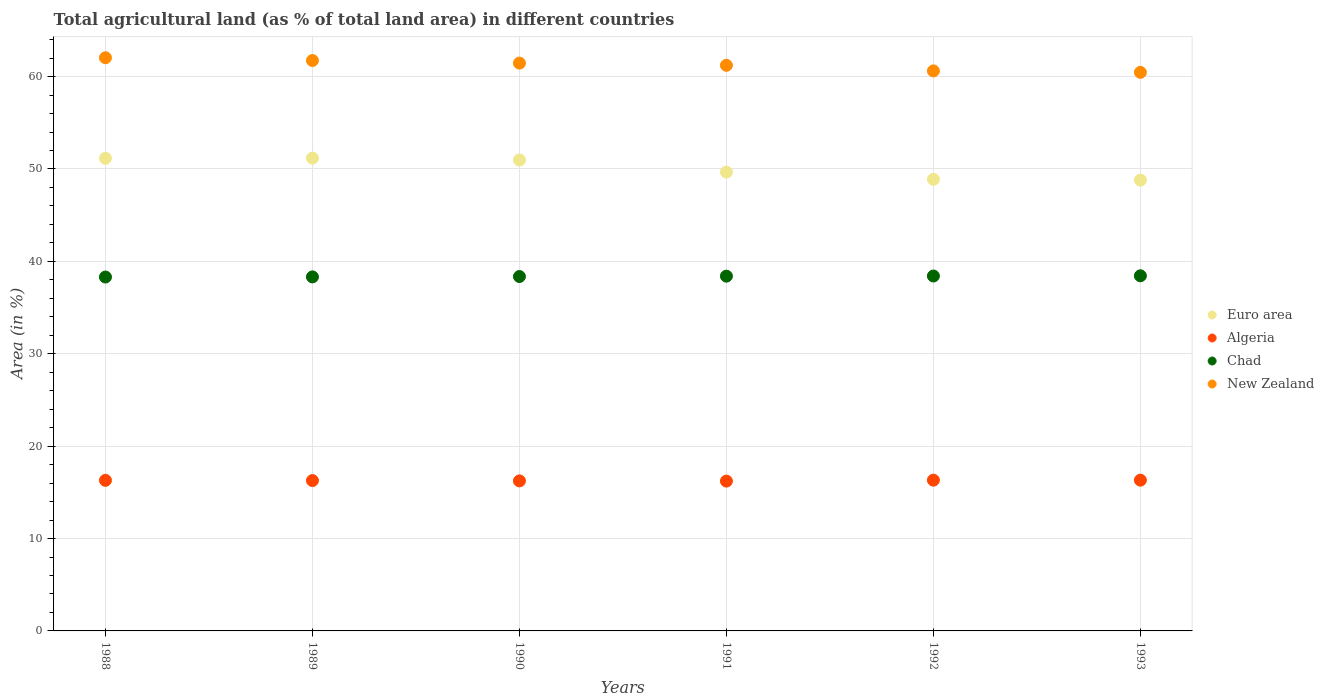How many different coloured dotlines are there?
Your answer should be compact. 4. Is the number of dotlines equal to the number of legend labels?
Make the answer very short. Yes. What is the percentage of agricultural land in Euro area in 1990?
Provide a short and direct response. 50.97. Across all years, what is the maximum percentage of agricultural land in Algeria?
Give a very brief answer. 16.32. Across all years, what is the minimum percentage of agricultural land in Algeria?
Offer a very short reply. 16.22. In which year was the percentage of agricultural land in Euro area maximum?
Your response must be concise. 1989. What is the total percentage of agricultural land in New Zealand in the graph?
Make the answer very short. 367.52. What is the difference between the percentage of agricultural land in Algeria in 1991 and that in 1993?
Provide a succinct answer. -0.1. What is the difference between the percentage of agricultural land in Algeria in 1993 and the percentage of agricultural land in New Zealand in 1989?
Give a very brief answer. -45.42. What is the average percentage of agricultural land in Chad per year?
Give a very brief answer. 38.37. In the year 1992, what is the difference between the percentage of agricultural land in Algeria and percentage of agricultural land in Chad?
Offer a very short reply. -22.1. In how many years, is the percentage of agricultural land in Euro area greater than 44 %?
Offer a terse response. 6. What is the ratio of the percentage of agricultural land in New Zealand in 1988 to that in 1991?
Keep it short and to the point. 1.01. What is the difference between the highest and the second highest percentage of agricultural land in Chad?
Provide a succinct answer. 0.02. What is the difference between the highest and the lowest percentage of agricultural land in Euro area?
Your answer should be compact. 2.38. In how many years, is the percentage of agricultural land in Algeria greater than the average percentage of agricultural land in Algeria taken over all years?
Offer a very short reply. 3. Is it the case that in every year, the sum of the percentage of agricultural land in Chad and percentage of agricultural land in New Zealand  is greater than the percentage of agricultural land in Euro area?
Keep it short and to the point. Yes. Does the percentage of agricultural land in Chad monotonically increase over the years?
Make the answer very short. Yes. Is the percentage of agricultural land in Chad strictly greater than the percentage of agricultural land in Euro area over the years?
Your response must be concise. No. What is the difference between two consecutive major ticks on the Y-axis?
Keep it short and to the point. 10. Are the values on the major ticks of Y-axis written in scientific E-notation?
Keep it short and to the point. No. Does the graph contain any zero values?
Give a very brief answer. No. What is the title of the graph?
Provide a short and direct response. Total agricultural land (as % of total land area) in different countries. What is the label or title of the X-axis?
Offer a terse response. Years. What is the label or title of the Y-axis?
Offer a terse response. Area (in %). What is the Area (in %) of Euro area in 1988?
Give a very brief answer. 51.15. What is the Area (in %) in Algeria in 1988?
Keep it short and to the point. 16.3. What is the Area (in %) in Chad in 1988?
Provide a succinct answer. 38.3. What is the Area (in %) of New Zealand in 1988?
Your answer should be very brief. 62.04. What is the Area (in %) in Euro area in 1989?
Make the answer very short. 51.18. What is the Area (in %) of Algeria in 1989?
Your answer should be very brief. 16.27. What is the Area (in %) in Chad in 1989?
Your answer should be very brief. 38.32. What is the Area (in %) of New Zealand in 1989?
Your answer should be very brief. 61.74. What is the Area (in %) in Euro area in 1990?
Offer a very short reply. 50.97. What is the Area (in %) in Algeria in 1990?
Your answer should be very brief. 16.24. What is the Area (in %) of Chad in 1990?
Ensure brevity in your answer.  38.36. What is the Area (in %) of New Zealand in 1990?
Provide a succinct answer. 61.46. What is the Area (in %) of Euro area in 1991?
Your answer should be very brief. 49.66. What is the Area (in %) in Algeria in 1991?
Your response must be concise. 16.22. What is the Area (in %) of Chad in 1991?
Provide a succinct answer. 38.4. What is the Area (in %) in New Zealand in 1991?
Ensure brevity in your answer.  61.22. What is the Area (in %) in Euro area in 1992?
Offer a terse response. 48.88. What is the Area (in %) of Algeria in 1992?
Make the answer very short. 16.32. What is the Area (in %) of Chad in 1992?
Give a very brief answer. 38.41. What is the Area (in %) of New Zealand in 1992?
Your answer should be very brief. 60.61. What is the Area (in %) of Euro area in 1993?
Give a very brief answer. 48.79. What is the Area (in %) in Algeria in 1993?
Give a very brief answer. 16.32. What is the Area (in %) of Chad in 1993?
Your answer should be very brief. 38.44. What is the Area (in %) in New Zealand in 1993?
Your response must be concise. 60.46. Across all years, what is the maximum Area (in %) of Euro area?
Your answer should be very brief. 51.18. Across all years, what is the maximum Area (in %) in Algeria?
Keep it short and to the point. 16.32. Across all years, what is the maximum Area (in %) in Chad?
Ensure brevity in your answer.  38.44. Across all years, what is the maximum Area (in %) in New Zealand?
Your response must be concise. 62.04. Across all years, what is the minimum Area (in %) of Euro area?
Provide a short and direct response. 48.79. Across all years, what is the minimum Area (in %) in Algeria?
Your response must be concise. 16.22. Across all years, what is the minimum Area (in %) in Chad?
Give a very brief answer. 38.3. Across all years, what is the minimum Area (in %) in New Zealand?
Ensure brevity in your answer.  60.46. What is the total Area (in %) of Euro area in the graph?
Your response must be concise. 300.64. What is the total Area (in %) in Algeria in the graph?
Keep it short and to the point. 97.66. What is the total Area (in %) in Chad in the graph?
Your answer should be very brief. 230.23. What is the total Area (in %) of New Zealand in the graph?
Make the answer very short. 367.52. What is the difference between the Area (in %) of Euro area in 1988 and that in 1989?
Make the answer very short. -0.02. What is the difference between the Area (in %) in Algeria in 1988 and that in 1989?
Make the answer very short. 0.02. What is the difference between the Area (in %) in Chad in 1988 and that in 1989?
Provide a succinct answer. -0.02. What is the difference between the Area (in %) of Euro area in 1988 and that in 1990?
Your response must be concise. 0.18. What is the difference between the Area (in %) in Algeria in 1988 and that in 1990?
Your answer should be compact. 0.06. What is the difference between the Area (in %) of Chad in 1988 and that in 1990?
Ensure brevity in your answer.  -0.06. What is the difference between the Area (in %) in New Zealand in 1988 and that in 1990?
Your response must be concise. 0.58. What is the difference between the Area (in %) in Euro area in 1988 and that in 1991?
Provide a short and direct response. 1.5. What is the difference between the Area (in %) of Algeria in 1988 and that in 1991?
Offer a terse response. 0.08. What is the difference between the Area (in %) of Chad in 1988 and that in 1991?
Make the answer very short. -0.1. What is the difference between the Area (in %) in New Zealand in 1988 and that in 1991?
Your answer should be compact. 0.82. What is the difference between the Area (in %) of Euro area in 1988 and that in 1992?
Give a very brief answer. 2.27. What is the difference between the Area (in %) of Algeria in 1988 and that in 1992?
Your response must be concise. -0.02. What is the difference between the Area (in %) in Chad in 1988 and that in 1992?
Give a very brief answer. -0.11. What is the difference between the Area (in %) of New Zealand in 1988 and that in 1992?
Your answer should be compact. 1.42. What is the difference between the Area (in %) in Euro area in 1988 and that in 1993?
Your response must be concise. 2.36. What is the difference between the Area (in %) of Algeria in 1988 and that in 1993?
Your answer should be very brief. -0.02. What is the difference between the Area (in %) of Chad in 1988 and that in 1993?
Your answer should be compact. -0.14. What is the difference between the Area (in %) of New Zealand in 1988 and that in 1993?
Offer a very short reply. 1.58. What is the difference between the Area (in %) of Euro area in 1989 and that in 1990?
Offer a very short reply. 0.2. What is the difference between the Area (in %) in Algeria in 1989 and that in 1990?
Your answer should be compact. 0.04. What is the difference between the Area (in %) in Chad in 1989 and that in 1990?
Keep it short and to the point. -0.04. What is the difference between the Area (in %) in New Zealand in 1989 and that in 1990?
Offer a very short reply. 0.28. What is the difference between the Area (in %) of Euro area in 1989 and that in 1991?
Make the answer very short. 1.52. What is the difference between the Area (in %) in Algeria in 1989 and that in 1991?
Offer a very short reply. 0.06. What is the difference between the Area (in %) of Chad in 1989 and that in 1991?
Provide a succinct answer. -0.08. What is the difference between the Area (in %) in New Zealand in 1989 and that in 1991?
Give a very brief answer. 0.52. What is the difference between the Area (in %) in Euro area in 1989 and that in 1992?
Provide a succinct answer. 2.3. What is the difference between the Area (in %) in Algeria in 1989 and that in 1992?
Keep it short and to the point. -0.04. What is the difference between the Area (in %) in Chad in 1989 and that in 1992?
Offer a terse response. -0.1. What is the difference between the Area (in %) of New Zealand in 1989 and that in 1992?
Provide a short and direct response. 1.12. What is the difference between the Area (in %) in Euro area in 1989 and that in 1993?
Ensure brevity in your answer.  2.38. What is the difference between the Area (in %) in Algeria in 1989 and that in 1993?
Ensure brevity in your answer.  -0.04. What is the difference between the Area (in %) of Chad in 1989 and that in 1993?
Ensure brevity in your answer.  -0.12. What is the difference between the Area (in %) in New Zealand in 1989 and that in 1993?
Offer a very short reply. 1.28. What is the difference between the Area (in %) in Euro area in 1990 and that in 1991?
Your answer should be compact. 1.31. What is the difference between the Area (in %) of Algeria in 1990 and that in 1991?
Keep it short and to the point. 0.02. What is the difference between the Area (in %) of Chad in 1990 and that in 1991?
Your answer should be very brief. -0.04. What is the difference between the Area (in %) in New Zealand in 1990 and that in 1991?
Offer a very short reply. 0.24. What is the difference between the Area (in %) in Euro area in 1990 and that in 1992?
Give a very brief answer. 2.09. What is the difference between the Area (in %) in Algeria in 1990 and that in 1992?
Offer a very short reply. -0.08. What is the difference between the Area (in %) in Chad in 1990 and that in 1992?
Provide a short and direct response. -0.06. What is the difference between the Area (in %) in New Zealand in 1990 and that in 1992?
Your answer should be compact. 0.84. What is the difference between the Area (in %) in Euro area in 1990 and that in 1993?
Your answer should be very brief. 2.18. What is the difference between the Area (in %) of Algeria in 1990 and that in 1993?
Ensure brevity in your answer.  -0.08. What is the difference between the Area (in %) in Chad in 1990 and that in 1993?
Your response must be concise. -0.08. What is the difference between the Area (in %) in New Zealand in 1990 and that in 1993?
Offer a very short reply. 1. What is the difference between the Area (in %) of Euro area in 1991 and that in 1992?
Provide a succinct answer. 0.78. What is the difference between the Area (in %) in Algeria in 1991 and that in 1992?
Provide a short and direct response. -0.1. What is the difference between the Area (in %) in Chad in 1991 and that in 1992?
Offer a very short reply. -0.02. What is the difference between the Area (in %) of New Zealand in 1991 and that in 1992?
Your response must be concise. 0.6. What is the difference between the Area (in %) in Euro area in 1991 and that in 1993?
Your response must be concise. 0.86. What is the difference between the Area (in %) of Algeria in 1991 and that in 1993?
Your response must be concise. -0.1. What is the difference between the Area (in %) in Chad in 1991 and that in 1993?
Offer a terse response. -0.04. What is the difference between the Area (in %) of New Zealand in 1991 and that in 1993?
Your answer should be compact. 0.76. What is the difference between the Area (in %) in Euro area in 1992 and that in 1993?
Offer a very short reply. 0.09. What is the difference between the Area (in %) in Algeria in 1992 and that in 1993?
Your answer should be very brief. 0. What is the difference between the Area (in %) in Chad in 1992 and that in 1993?
Offer a terse response. -0.02. What is the difference between the Area (in %) in New Zealand in 1992 and that in 1993?
Keep it short and to the point. 0.16. What is the difference between the Area (in %) in Euro area in 1988 and the Area (in %) in Algeria in 1989?
Provide a succinct answer. 34.88. What is the difference between the Area (in %) in Euro area in 1988 and the Area (in %) in Chad in 1989?
Your answer should be very brief. 12.84. What is the difference between the Area (in %) of Euro area in 1988 and the Area (in %) of New Zealand in 1989?
Give a very brief answer. -10.58. What is the difference between the Area (in %) in Algeria in 1988 and the Area (in %) in Chad in 1989?
Make the answer very short. -22.02. What is the difference between the Area (in %) of Algeria in 1988 and the Area (in %) of New Zealand in 1989?
Your answer should be very brief. -45.44. What is the difference between the Area (in %) of Chad in 1988 and the Area (in %) of New Zealand in 1989?
Offer a very short reply. -23.43. What is the difference between the Area (in %) in Euro area in 1988 and the Area (in %) in Algeria in 1990?
Give a very brief answer. 34.92. What is the difference between the Area (in %) of Euro area in 1988 and the Area (in %) of Chad in 1990?
Give a very brief answer. 12.8. What is the difference between the Area (in %) of Euro area in 1988 and the Area (in %) of New Zealand in 1990?
Your answer should be very brief. -10.3. What is the difference between the Area (in %) in Algeria in 1988 and the Area (in %) in Chad in 1990?
Your answer should be compact. -22.06. What is the difference between the Area (in %) in Algeria in 1988 and the Area (in %) in New Zealand in 1990?
Offer a very short reply. -45.16. What is the difference between the Area (in %) of Chad in 1988 and the Area (in %) of New Zealand in 1990?
Keep it short and to the point. -23.15. What is the difference between the Area (in %) of Euro area in 1988 and the Area (in %) of Algeria in 1991?
Keep it short and to the point. 34.94. What is the difference between the Area (in %) of Euro area in 1988 and the Area (in %) of Chad in 1991?
Your response must be concise. 12.76. What is the difference between the Area (in %) of Euro area in 1988 and the Area (in %) of New Zealand in 1991?
Provide a short and direct response. -10.06. What is the difference between the Area (in %) in Algeria in 1988 and the Area (in %) in Chad in 1991?
Keep it short and to the point. -22.1. What is the difference between the Area (in %) in Algeria in 1988 and the Area (in %) in New Zealand in 1991?
Ensure brevity in your answer.  -44.92. What is the difference between the Area (in %) in Chad in 1988 and the Area (in %) in New Zealand in 1991?
Provide a short and direct response. -22.91. What is the difference between the Area (in %) in Euro area in 1988 and the Area (in %) in Algeria in 1992?
Your answer should be compact. 34.84. What is the difference between the Area (in %) of Euro area in 1988 and the Area (in %) of Chad in 1992?
Offer a very short reply. 12.74. What is the difference between the Area (in %) in Euro area in 1988 and the Area (in %) in New Zealand in 1992?
Give a very brief answer. -9.46. What is the difference between the Area (in %) in Algeria in 1988 and the Area (in %) in Chad in 1992?
Provide a short and direct response. -22.12. What is the difference between the Area (in %) of Algeria in 1988 and the Area (in %) of New Zealand in 1992?
Provide a short and direct response. -44.32. What is the difference between the Area (in %) of Chad in 1988 and the Area (in %) of New Zealand in 1992?
Make the answer very short. -22.31. What is the difference between the Area (in %) in Euro area in 1988 and the Area (in %) in Algeria in 1993?
Offer a terse response. 34.84. What is the difference between the Area (in %) of Euro area in 1988 and the Area (in %) of Chad in 1993?
Offer a very short reply. 12.72. What is the difference between the Area (in %) in Euro area in 1988 and the Area (in %) in New Zealand in 1993?
Give a very brief answer. -9.3. What is the difference between the Area (in %) of Algeria in 1988 and the Area (in %) of Chad in 1993?
Offer a terse response. -22.14. What is the difference between the Area (in %) of Algeria in 1988 and the Area (in %) of New Zealand in 1993?
Ensure brevity in your answer.  -44.16. What is the difference between the Area (in %) of Chad in 1988 and the Area (in %) of New Zealand in 1993?
Your answer should be very brief. -22.16. What is the difference between the Area (in %) in Euro area in 1989 and the Area (in %) in Algeria in 1990?
Provide a succinct answer. 34.94. What is the difference between the Area (in %) in Euro area in 1989 and the Area (in %) in Chad in 1990?
Provide a succinct answer. 12.82. What is the difference between the Area (in %) of Euro area in 1989 and the Area (in %) of New Zealand in 1990?
Provide a succinct answer. -10.28. What is the difference between the Area (in %) of Algeria in 1989 and the Area (in %) of Chad in 1990?
Keep it short and to the point. -22.08. What is the difference between the Area (in %) in Algeria in 1989 and the Area (in %) in New Zealand in 1990?
Provide a short and direct response. -45.18. What is the difference between the Area (in %) in Chad in 1989 and the Area (in %) in New Zealand in 1990?
Make the answer very short. -23.14. What is the difference between the Area (in %) in Euro area in 1989 and the Area (in %) in Algeria in 1991?
Keep it short and to the point. 34.96. What is the difference between the Area (in %) of Euro area in 1989 and the Area (in %) of Chad in 1991?
Give a very brief answer. 12.78. What is the difference between the Area (in %) of Euro area in 1989 and the Area (in %) of New Zealand in 1991?
Offer a very short reply. -10.04. What is the difference between the Area (in %) of Algeria in 1989 and the Area (in %) of Chad in 1991?
Give a very brief answer. -22.12. What is the difference between the Area (in %) of Algeria in 1989 and the Area (in %) of New Zealand in 1991?
Your answer should be compact. -44.94. What is the difference between the Area (in %) in Chad in 1989 and the Area (in %) in New Zealand in 1991?
Provide a succinct answer. -22.9. What is the difference between the Area (in %) of Euro area in 1989 and the Area (in %) of Algeria in 1992?
Keep it short and to the point. 34.86. What is the difference between the Area (in %) in Euro area in 1989 and the Area (in %) in Chad in 1992?
Offer a terse response. 12.76. What is the difference between the Area (in %) in Euro area in 1989 and the Area (in %) in New Zealand in 1992?
Offer a terse response. -9.44. What is the difference between the Area (in %) in Algeria in 1989 and the Area (in %) in Chad in 1992?
Make the answer very short. -22.14. What is the difference between the Area (in %) of Algeria in 1989 and the Area (in %) of New Zealand in 1992?
Make the answer very short. -44.34. What is the difference between the Area (in %) in Chad in 1989 and the Area (in %) in New Zealand in 1992?
Offer a terse response. -22.3. What is the difference between the Area (in %) of Euro area in 1989 and the Area (in %) of Algeria in 1993?
Offer a terse response. 34.86. What is the difference between the Area (in %) of Euro area in 1989 and the Area (in %) of Chad in 1993?
Keep it short and to the point. 12.74. What is the difference between the Area (in %) in Euro area in 1989 and the Area (in %) in New Zealand in 1993?
Offer a terse response. -9.28. What is the difference between the Area (in %) of Algeria in 1989 and the Area (in %) of Chad in 1993?
Your response must be concise. -22.16. What is the difference between the Area (in %) of Algeria in 1989 and the Area (in %) of New Zealand in 1993?
Your answer should be very brief. -44.18. What is the difference between the Area (in %) in Chad in 1989 and the Area (in %) in New Zealand in 1993?
Your answer should be very brief. -22.14. What is the difference between the Area (in %) of Euro area in 1990 and the Area (in %) of Algeria in 1991?
Ensure brevity in your answer.  34.76. What is the difference between the Area (in %) of Euro area in 1990 and the Area (in %) of Chad in 1991?
Ensure brevity in your answer.  12.57. What is the difference between the Area (in %) in Euro area in 1990 and the Area (in %) in New Zealand in 1991?
Provide a succinct answer. -10.24. What is the difference between the Area (in %) in Algeria in 1990 and the Area (in %) in Chad in 1991?
Offer a very short reply. -22.16. What is the difference between the Area (in %) in Algeria in 1990 and the Area (in %) in New Zealand in 1991?
Your response must be concise. -44.98. What is the difference between the Area (in %) in Chad in 1990 and the Area (in %) in New Zealand in 1991?
Your response must be concise. -22.86. What is the difference between the Area (in %) in Euro area in 1990 and the Area (in %) in Algeria in 1992?
Your answer should be compact. 34.65. What is the difference between the Area (in %) in Euro area in 1990 and the Area (in %) in Chad in 1992?
Your answer should be compact. 12.56. What is the difference between the Area (in %) of Euro area in 1990 and the Area (in %) of New Zealand in 1992?
Provide a succinct answer. -9.64. What is the difference between the Area (in %) in Algeria in 1990 and the Area (in %) in Chad in 1992?
Your answer should be compact. -22.17. What is the difference between the Area (in %) in Algeria in 1990 and the Area (in %) in New Zealand in 1992?
Provide a succinct answer. -44.37. What is the difference between the Area (in %) in Chad in 1990 and the Area (in %) in New Zealand in 1992?
Give a very brief answer. -22.26. What is the difference between the Area (in %) in Euro area in 1990 and the Area (in %) in Algeria in 1993?
Your response must be concise. 34.66. What is the difference between the Area (in %) of Euro area in 1990 and the Area (in %) of Chad in 1993?
Make the answer very short. 12.53. What is the difference between the Area (in %) of Euro area in 1990 and the Area (in %) of New Zealand in 1993?
Your response must be concise. -9.49. What is the difference between the Area (in %) of Algeria in 1990 and the Area (in %) of Chad in 1993?
Offer a very short reply. -22.2. What is the difference between the Area (in %) of Algeria in 1990 and the Area (in %) of New Zealand in 1993?
Provide a succinct answer. -44.22. What is the difference between the Area (in %) in Chad in 1990 and the Area (in %) in New Zealand in 1993?
Make the answer very short. -22.1. What is the difference between the Area (in %) of Euro area in 1991 and the Area (in %) of Algeria in 1992?
Ensure brevity in your answer.  33.34. What is the difference between the Area (in %) of Euro area in 1991 and the Area (in %) of Chad in 1992?
Provide a succinct answer. 11.25. What is the difference between the Area (in %) in Euro area in 1991 and the Area (in %) in New Zealand in 1992?
Your answer should be compact. -10.95. What is the difference between the Area (in %) in Algeria in 1991 and the Area (in %) in Chad in 1992?
Offer a very short reply. -22.2. What is the difference between the Area (in %) in Algeria in 1991 and the Area (in %) in New Zealand in 1992?
Your response must be concise. -44.4. What is the difference between the Area (in %) of Chad in 1991 and the Area (in %) of New Zealand in 1992?
Your response must be concise. -22.22. What is the difference between the Area (in %) in Euro area in 1991 and the Area (in %) in Algeria in 1993?
Your answer should be very brief. 33.34. What is the difference between the Area (in %) in Euro area in 1991 and the Area (in %) in Chad in 1993?
Provide a short and direct response. 11.22. What is the difference between the Area (in %) of Euro area in 1991 and the Area (in %) of New Zealand in 1993?
Your answer should be very brief. -10.8. What is the difference between the Area (in %) in Algeria in 1991 and the Area (in %) in Chad in 1993?
Keep it short and to the point. -22.22. What is the difference between the Area (in %) in Algeria in 1991 and the Area (in %) in New Zealand in 1993?
Offer a very short reply. -44.24. What is the difference between the Area (in %) of Chad in 1991 and the Area (in %) of New Zealand in 1993?
Your answer should be compact. -22.06. What is the difference between the Area (in %) in Euro area in 1992 and the Area (in %) in Algeria in 1993?
Your response must be concise. 32.56. What is the difference between the Area (in %) of Euro area in 1992 and the Area (in %) of Chad in 1993?
Your answer should be compact. 10.44. What is the difference between the Area (in %) in Euro area in 1992 and the Area (in %) in New Zealand in 1993?
Make the answer very short. -11.58. What is the difference between the Area (in %) of Algeria in 1992 and the Area (in %) of Chad in 1993?
Provide a succinct answer. -22.12. What is the difference between the Area (in %) in Algeria in 1992 and the Area (in %) in New Zealand in 1993?
Your answer should be very brief. -44.14. What is the difference between the Area (in %) of Chad in 1992 and the Area (in %) of New Zealand in 1993?
Offer a very short reply. -22.04. What is the average Area (in %) of Euro area per year?
Your answer should be compact. 50.11. What is the average Area (in %) in Algeria per year?
Offer a very short reply. 16.28. What is the average Area (in %) of Chad per year?
Offer a very short reply. 38.37. What is the average Area (in %) in New Zealand per year?
Keep it short and to the point. 61.25. In the year 1988, what is the difference between the Area (in %) of Euro area and Area (in %) of Algeria?
Make the answer very short. 34.86. In the year 1988, what is the difference between the Area (in %) in Euro area and Area (in %) in Chad?
Give a very brief answer. 12.85. In the year 1988, what is the difference between the Area (in %) in Euro area and Area (in %) in New Zealand?
Your answer should be very brief. -10.88. In the year 1988, what is the difference between the Area (in %) of Algeria and Area (in %) of Chad?
Give a very brief answer. -22. In the year 1988, what is the difference between the Area (in %) in Algeria and Area (in %) in New Zealand?
Offer a terse response. -45.74. In the year 1988, what is the difference between the Area (in %) of Chad and Area (in %) of New Zealand?
Offer a very short reply. -23.73. In the year 1989, what is the difference between the Area (in %) of Euro area and Area (in %) of Algeria?
Make the answer very short. 34.9. In the year 1989, what is the difference between the Area (in %) in Euro area and Area (in %) in Chad?
Provide a short and direct response. 12.86. In the year 1989, what is the difference between the Area (in %) in Euro area and Area (in %) in New Zealand?
Offer a very short reply. -10.56. In the year 1989, what is the difference between the Area (in %) of Algeria and Area (in %) of Chad?
Your answer should be compact. -22.04. In the year 1989, what is the difference between the Area (in %) of Algeria and Area (in %) of New Zealand?
Ensure brevity in your answer.  -45.46. In the year 1989, what is the difference between the Area (in %) of Chad and Area (in %) of New Zealand?
Keep it short and to the point. -23.42. In the year 1990, what is the difference between the Area (in %) in Euro area and Area (in %) in Algeria?
Give a very brief answer. 34.73. In the year 1990, what is the difference between the Area (in %) of Euro area and Area (in %) of Chad?
Your response must be concise. 12.61. In the year 1990, what is the difference between the Area (in %) of Euro area and Area (in %) of New Zealand?
Your answer should be very brief. -10.48. In the year 1990, what is the difference between the Area (in %) of Algeria and Area (in %) of Chad?
Provide a succinct answer. -22.12. In the year 1990, what is the difference between the Area (in %) in Algeria and Area (in %) in New Zealand?
Provide a succinct answer. -45.22. In the year 1990, what is the difference between the Area (in %) in Chad and Area (in %) in New Zealand?
Keep it short and to the point. -23.1. In the year 1991, what is the difference between the Area (in %) of Euro area and Area (in %) of Algeria?
Offer a very short reply. 33.44. In the year 1991, what is the difference between the Area (in %) of Euro area and Area (in %) of Chad?
Give a very brief answer. 11.26. In the year 1991, what is the difference between the Area (in %) of Euro area and Area (in %) of New Zealand?
Offer a very short reply. -11.56. In the year 1991, what is the difference between the Area (in %) in Algeria and Area (in %) in Chad?
Keep it short and to the point. -22.18. In the year 1991, what is the difference between the Area (in %) in Algeria and Area (in %) in New Zealand?
Make the answer very short. -45. In the year 1991, what is the difference between the Area (in %) in Chad and Area (in %) in New Zealand?
Your response must be concise. -22.82. In the year 1992, what is the difference between the Area (in %) in Euro area and Area (in %) in Algeria?
Offer a very short reply. 32.56. In the year 1992, what is the difference between the Area (in %) in Euro area and Area (in %) in Chad?
Offer a terse response. 10.47. In the year 1992, what is the difference between the Area (in %) in Euro area and Area (in %) in New Zealand?
Give a very brief answer. -11.73. In the year 1992, what is the difference between the Area (in %) in Algeria and Area (in %) in Chad?
Make the answer very short. -22.1. In the year 1992, what is the difference between the Area (in %) in Algeria and Area (in %) in New Zealand?
Keep it short and to the point. -44.3. In the year 1992, what is the difference between the Area (in %) in Chad and Area (in %) in New Zealand?
Offer a terse response. -22.2. In the year 1993, what is the difference between the Area (in %) in Euro area and Area (in %) in Algeria?
Your answer should be very brief. 32.48. In the year 1993, what is the difference between the Area (in %) of Euro area and Area (in %) of Chad?
Your answer should be very brief. 10.36. In the year 1993, what is the difference between the Area (in %) in Euro area and Area (in %) in New Zealand?
Provide a succinct answer. -11.66. In the year 1993, what is the difference between the Area (in %) of Algeria and Area (in %) of Chad?
Give a very brief answer. -22.12. In the year 1993, what is the difference between the Area (in %) in Algeria and Area (in %) in New Zealand?
Offer a terse response. -44.14. In the year 1993, what is the difference between the Area (in %) of Chad and Area (in %) of New Zealand?
Keep it short and to the point. -22.02. What is the ratio of the Area (in %) of Euro area in 1988 to that in 1989?
Offer a terse response. 1. What is the ratio of the Area (in %) of Chad in 1988 to that in 1989?
Your answer should be very brief. 1. What is the ratio of the Area (in %) in New Zealand in 1988 to that in 1989?
Offer a terse response. 1. What is the ratio of the Area (in %) of Euro area in 1988 to that in 1990?
Your response must be concise. 1. What is the ratio of the Area (in %) of Algeria in 1988 to that in 1990?
Keep it short and to the point. 1. What is the ratio of the Area (in %) in New Zealand in 1988 to that in 1990?
Make the answer very short. 1.01. What is the ratio of the Area (in %) of Euro area in 1988 to that in 1991?
Offer a very short reply. 1.03. What is the ratio of the Area (in %) in Chad in 1988 to that in 1991?
Ensure brevity in your answer.  1. What is the ratio of the Area (in %) of New Zealand in 1988 to that in 1991?
Your answer should be very brief. 1.01. What is the ratio of the Area (in %) in Euro area in 1988 to that in 1992?
Make the answer very short. 1.05. What is the ratio of the Area (in %) in Algeria in 1988 to that in 1992?
Make the answer very short. 1. What is the ratio of the Area (in %) of New Zealand in 1988 to that in 1992?
Offer a terse response. 1.02. What is the ratio of the Area (in %) of Euro area in 1988 to that in 1993?
Your answer should be compact. 1.05. What is the ratio of the Area (in %) in Chad in 1988 to that in 1993?
Offer a very short reply. 1. What is the ratio of the Area (in %) in New Zealand in 1988 to that in 1993?
Ensure brevity in your answer.  1.03. What is the ratio of the Area (in %) in Euro area in 1989 to that in 1990?
Make the answer very short. 1. What is the ratio of the Area (in %) of New Zealand in 1989 to that in 1990?
Offer a terse response. 1. What is the ratio of the Area (in %) in Euro area in 1989 to that in 1991?
Your answer should be compact. 1.03. What is the ratio of the Area (in %) in New Zealand in 1989 to that in 1991?
Give a very brief answer. 1.01. What is the ratio of the Area (in %) of Euro area in 1989 to that in 1992?
Provide a succinct answer. 1.05. What is the ratio of the Area (in %) of New Zealand in 1989 to that in 1992?
Your answer should be very brief. 1.02. What is the ratio of the Area (in %) in Euro area in 1989 to that in 1993?
Ensure brevity in your answer.  1.05. What is the ratio of the Area (in %) of New Zealand in 1989 to that in 1993?
Offer a very short reply. 1.02. What is the ratio of the Area (in %) of Euro area in 1990 to that in 1991?
Offer a terse response. 1.03. What is the ratio of the Area (in %) in New Zealand in 1990 to that in 1991?
Provide a succinct answer. 1. What is the ratio of the Area (in %) in Euro area in 1990 to that in 1992?
Provide a short and direct response. 1.04. What is the ratio of the Area (in %) in Algeria in 1990 to that in 1992?
Offer a very short reply. 1. What is the ratio of the Area (in %) of Chad in 1990 to that in 1992?
Your answer should be compact. 1. What is the ratio of the Area (in %) in New Zealand in 1990 to that in 1992?
Keep it short and to the point. 1.01. What is the ratio of the Area (in %) of Euro area in 1990 to that in 1993?
Ensure brevity in your answer.  1.04. What is the ratio of the Area (in %) of New Zealand in 1990 to that in 1993?
Your answer should be compact. 1.02. What is the ratio of the Area (in %) in Euro area in 1991 to that in 1992?
Give a very brief answer. 1.02. What is the ratio of the Area (in %) in Euro area in 1991 to that in 1993?
Your answer should be compact. 1.02. What is the ratio of the Area (in %) in New Zealand in 1991 to that in 1993?
Give a very brief answer. 1.01. What is the difference between the highest and the second highest Area (in %) in Euro area?
Your answer should be compact. 0.02. What is the difference between the highest and the second highest Area (in %) in Algeria?
Your answer should be compact. 0. What is the difference between the highest and the second highest Area (in %) in Chad?
Offer a very short reply. 0.02. What is the difference between the highest and the lowest Area (in %) of Euro area?
Make the answer very short. 2.38. What is the difference between the highest and the lowest Area (in %) of Algeria?
Give a very brief answer. 0.1. What is the difference between the highest and the lowest Area (in %) of Chad?
Give a very brief answer. 0.14. What is the difference between the highest and the lowest Area (in %) in New Zealand?
Offer a terse response. 1.58. 